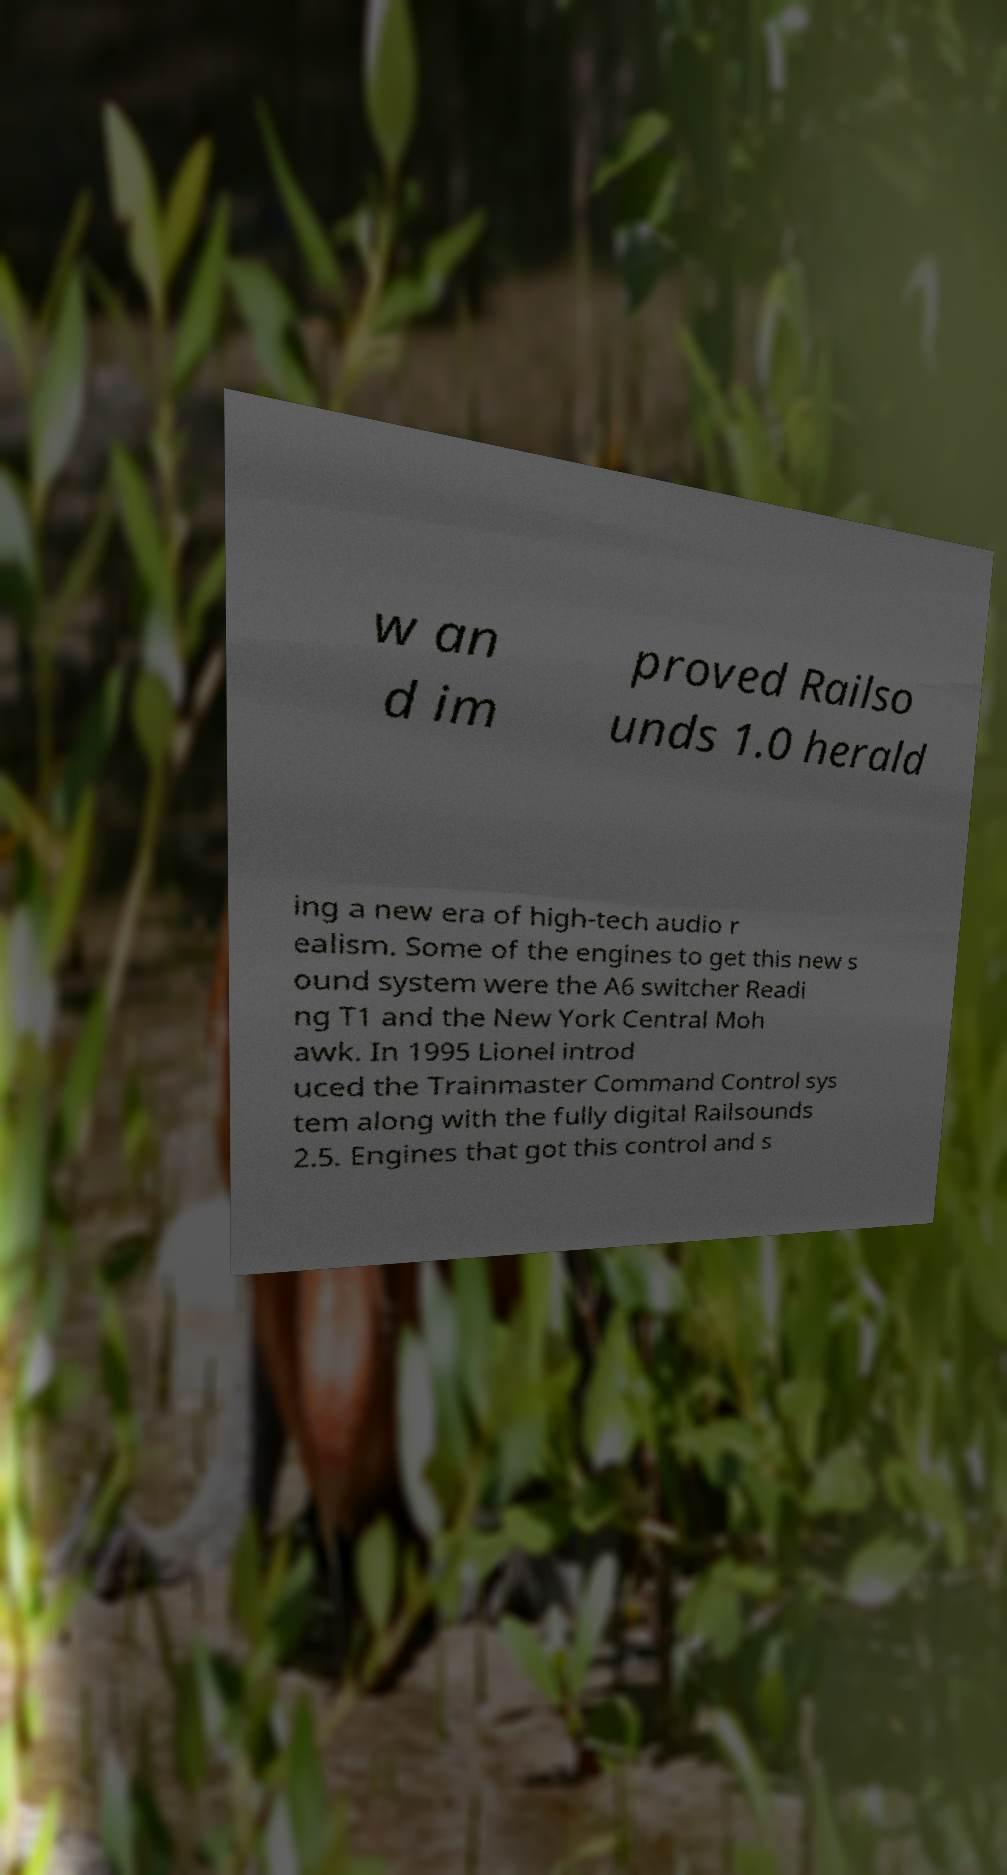What messages or text are displayed in this image? I need them in a readable, typed format. w an d im proved Railso unds 1.0 herald ing a new era of high-tech audio r ealism. Some of the engines to get this new s ound system were the A6 switcher Readi ng T1 and the New York Central Moh awk. In 1995 Lionel introd uced the Trainmaster Command Control sys tem along with the fully digital Railsounds 2.5. Engines that got this control and s 